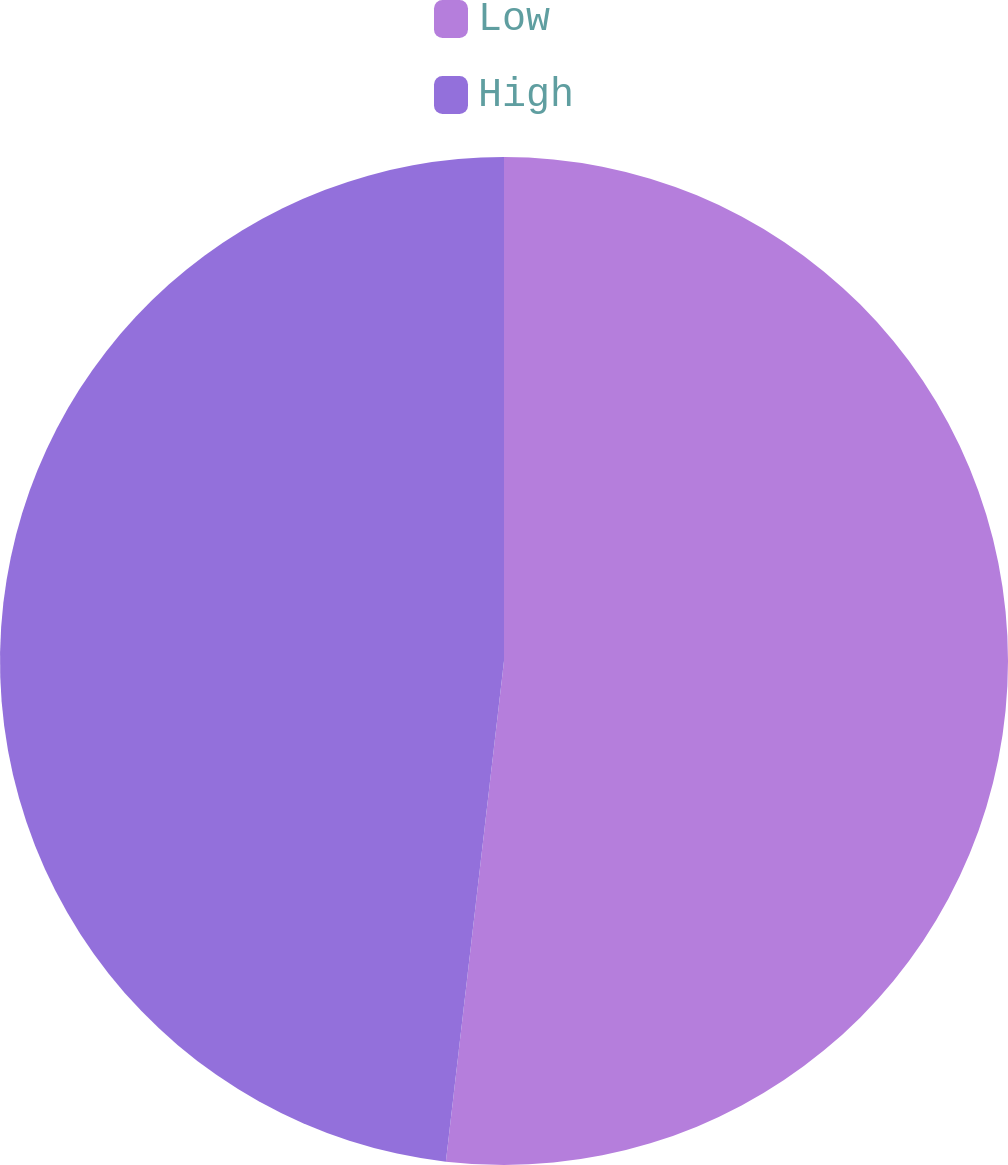<chart> <loc_0><loc_0><loc_500><loc_500><pie_chart><fcel>Low<fcel>High<nl><fcel>51.84%<fcel>48.16%<nl></chart> 